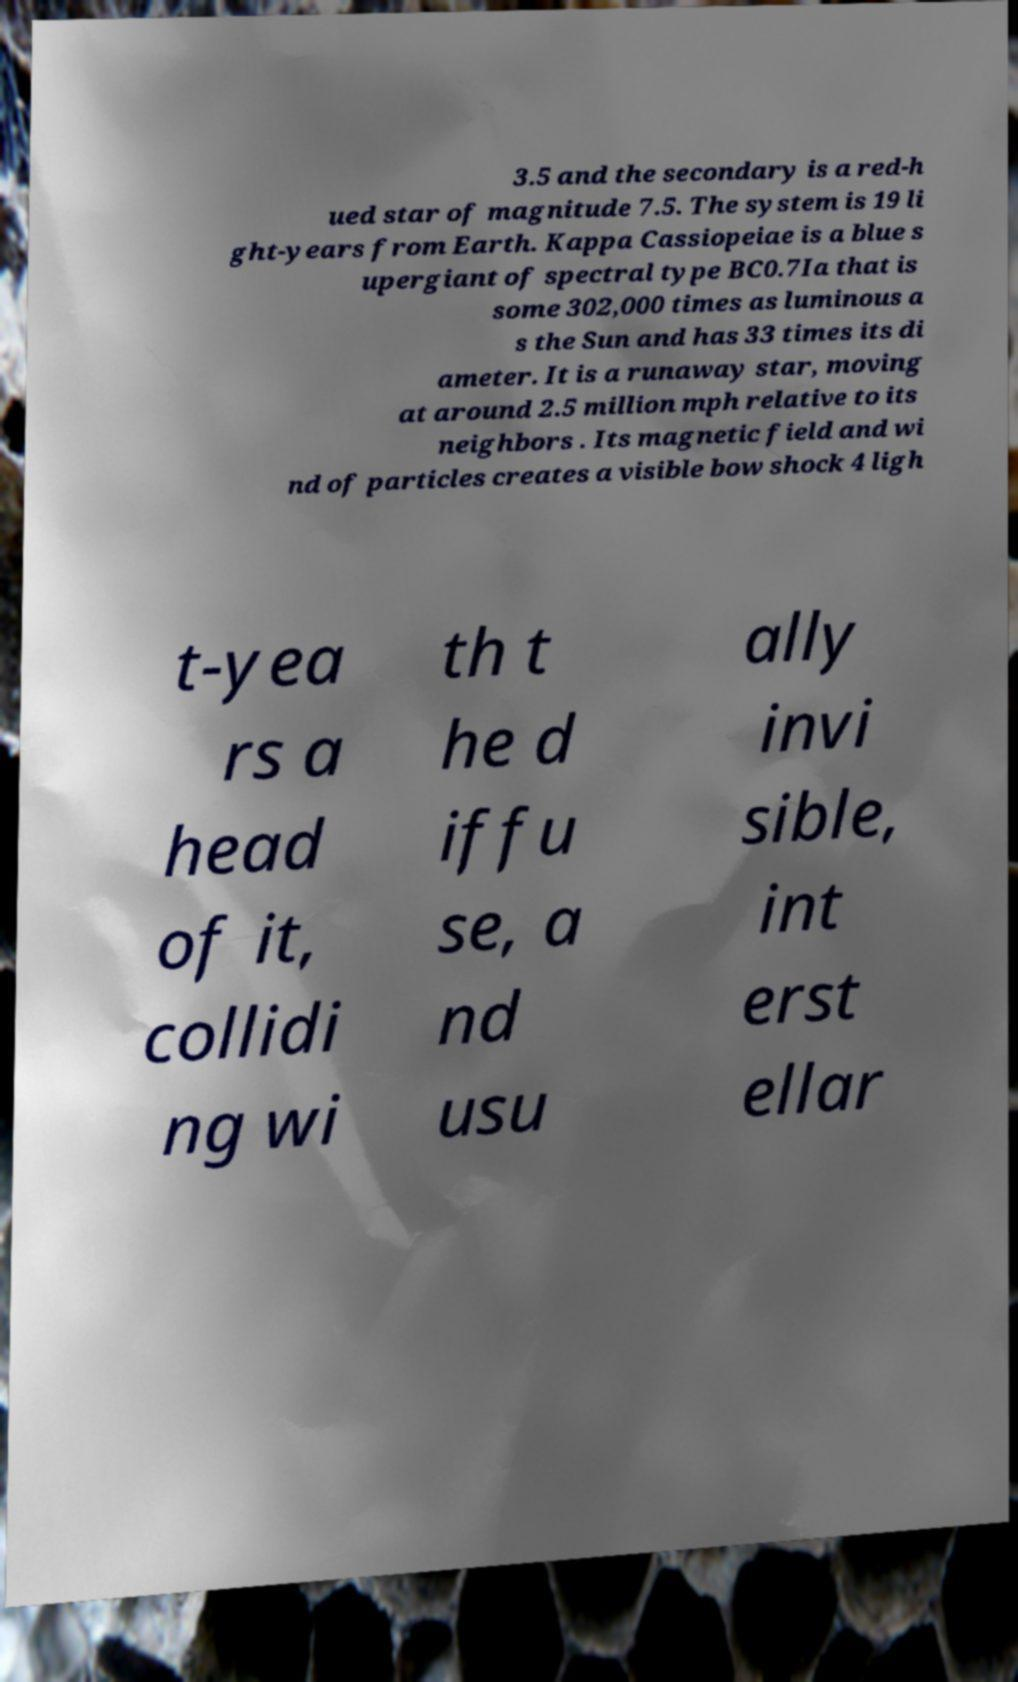Please read and relay the text visible in this image. What does it say? 3.5 and the secondary is a red-h ued star of magnitude 7.5. The system is 19 li ght-years from Earth. Kappa Cassiopeiae is a blue s upergiant of spectral type BC0.7Ia that is some 302,000 times as luminous a s the Sun and has 33 times its di ameter. It is a runaway star, moving at around 2.5 million mph relative to its neighbors . Its magnetic field and wi nd of particles creates a visible bow shock 4 ligh t-yea rs a head of it, collidi ng wi th t he d iffu se, a nd usu ally invi sible, int erst ellar 